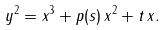<formula> <loc_0><loc_0><loc_500><loc_500>y ^ { 2 } = x ^ { 3 } + p ( s ) \, x ^ { 2 } + t \, x .</formula> 